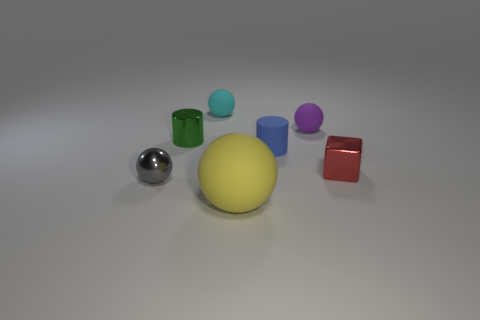Add 1 large spheres. How many objects exist? 8 Subtract all cylinders. How many objects are left? 5 Add 4 tiny metallic blocks. How many tiny metallic blocks exist? 5 Subtract 0 brown cylinders. How many objects are left? 7 Subtract all large gray metal balls. Subtract all shiny cylinders. How many objects are left? 6 Add 5 tiny gray balls. How many tiny gray balls are left? 6 